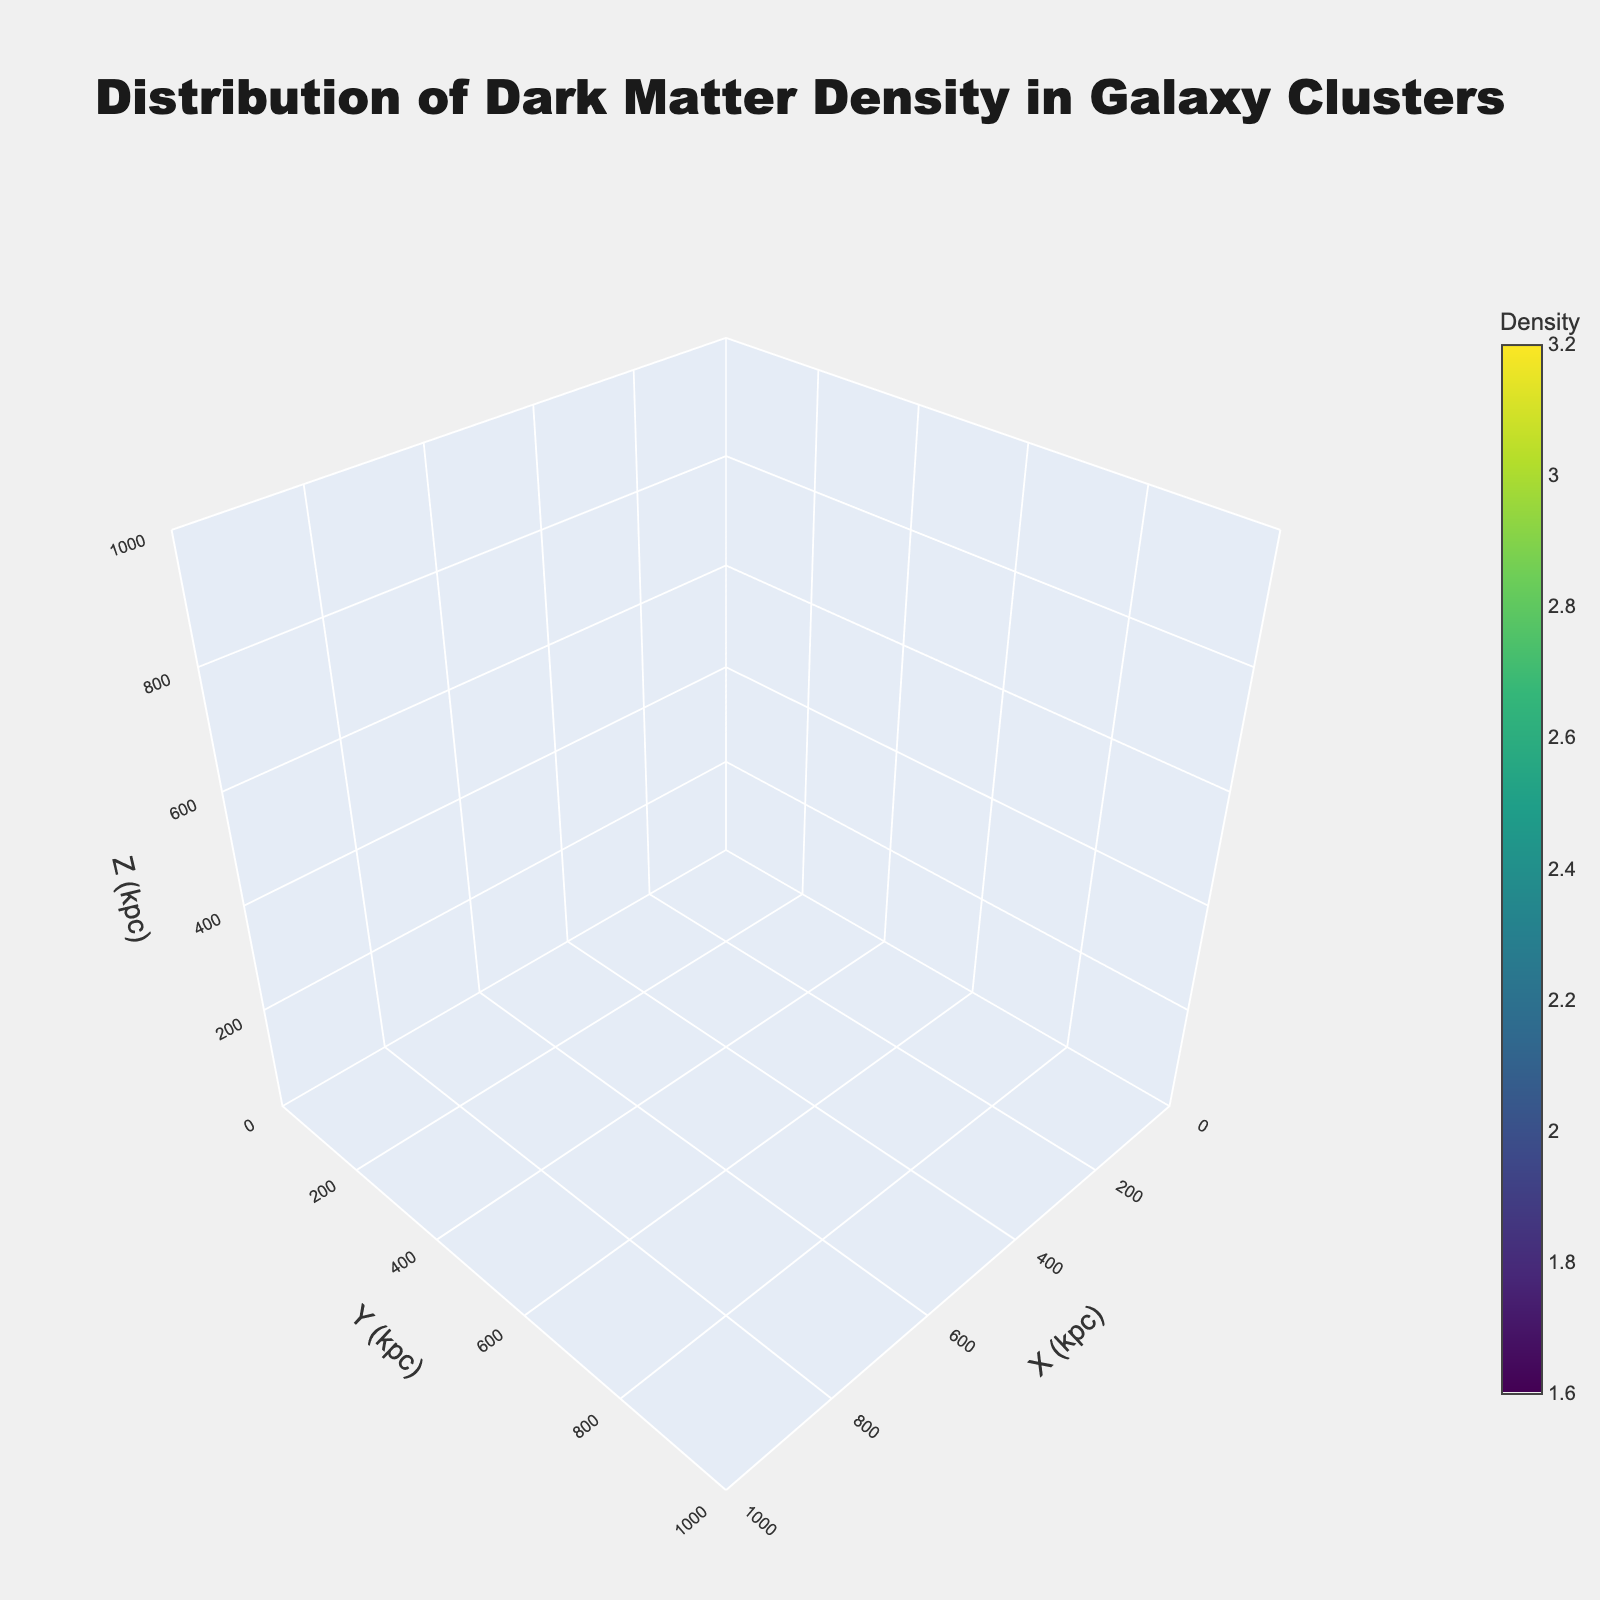What is the title of the figure? The title is typically displayed at the top of the plot and mentions what the figure represents. In this case, it is about the distribution of dark matter density in galaxy clusters.
Answer: Distribution of Dark Matter Density in Galaxy Clusters What are the labels of the axes in the plot? The labels for the axes are usually displayed along the axes to indicate what each dimension represents. For this figure, they are X, Y, and Z with units in kiloparsecs (kpc).
Answer: X (kpc), Y (kpc), Z (kpc) What is the range of values on the X-axis? The range of the X-axis can be identified by looking at the minimum and maximum values displayed along the X-axis. Here, it ranges from 0 to 1000 kpc.
Answer: 0 to 1000 kpc What is the color scale used in the plot? The color scale shows the gradient of color that represents different values of density. In this figure, the colorscale used is 'Viridis'.
Answer: Viridis What is the range of density values represented by the color bar? The color bar displays the minimum and maximum values of density that are covered in the plot. These can be read directly from the figure.
Answer: 1.6 to 3.2 Which point has the highest dark matter density and what is that value? To find the point with the highest density, we need to locate the highest value on the density color bar and identify the corresponding data point in the plot. The highest density value from the dataset is 3.2 at the coordinates (500, 500, 500).
Answer: (500, 500, 500) with a density of 3.2 How do the densities vary between the point (0,0,0) and (1000,1000,1000)? We can compare the density values at these two points by locating their coordinates in the figure and checking their corresponding densities. From the data, (0, 0, 0) has a density of 2.5 and (1000, 1000, 1000) has a density of 1.6.
Answer: The density decreases from 2.5 to 1.6 Is the highest density value found at the center of the galaxy cluster? To answer this, check where the highest density point (500, 500, 500) is located relative to the entire space. Since (500, 500, 500) lies at the center of the range 0 to 1000 for each axis, it can be considered the center.
Answer: Yes What can you infer about the distribution of higher density values in the plot? To infer the distribution, observe where in the 3D space the higher density colors (as per Viridis scale) are concentrated. High density clusters, like the one at (500, 500, 500) and other points such as (250, 250, 250), indicate a central clustering of higher densities.
Answer: Higher densities are concentrated centrally and reduce towards the edges 